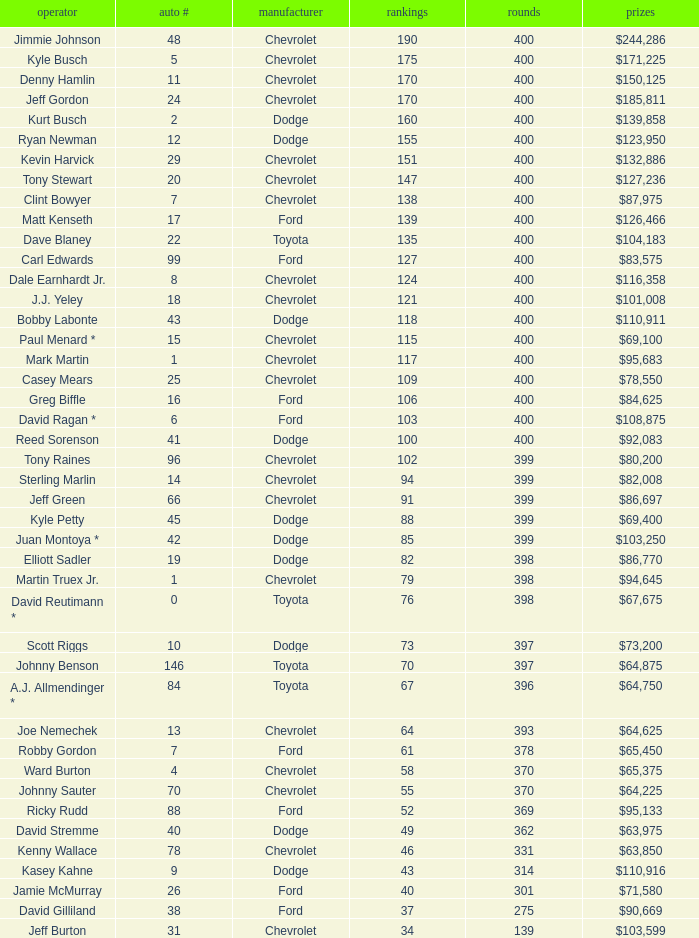What were the winnings for the Chevrolet with a number larger than 29 and scored 102 points? $80,200. 